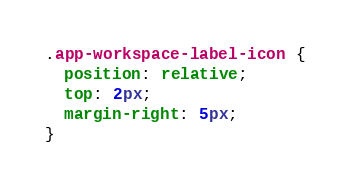Convert code to text. <code><loc_0><loc_0><loc_500><loc_500><_CSS_>.app-workspace-label-icon {
  position: relative;
  top: 2px;
  margin-right: 5px;
}
</code> 